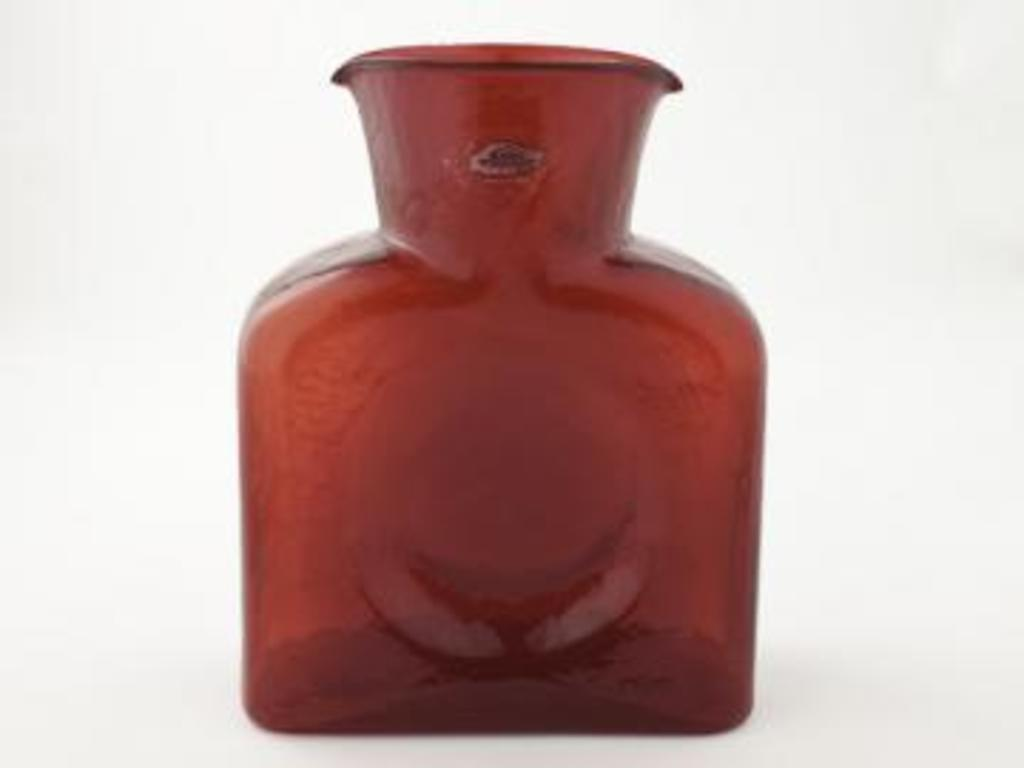What color is the mug in the image? The mug in the image is red. What color is the background of the image? The background of the image is white. What type of skin can be seen on the mug in the image? There is no skin visible on the mug in the image; it is a mug made of a non-organic material. 